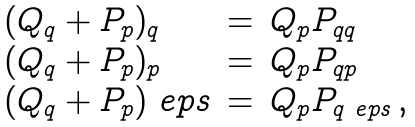<formula> <loc_0><loc_0><loc_500><loc_500>\begin{array} { l l l } ( Q _ { q } + P _ { p } ) _ { q } & = & Q _ { p } P _ { q q } \\ ( Q _ { q } + P _ { p } ) _ { p } & = & Q _ { p } P _ { q p } \\ ( Q _ { q } + P _ { p } ) _ { \ } e p s & = & Q _ { p } P _ { q \ e p s } \, , \\ \end{array}</formula> 